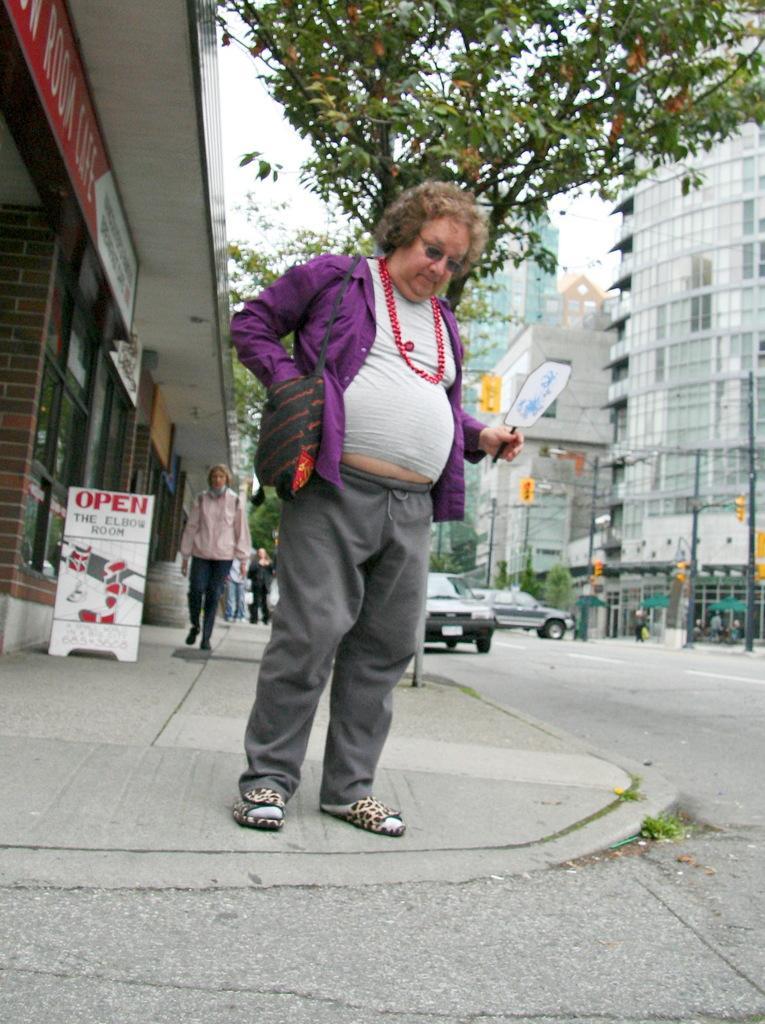Describe this image in one or two sentences. In this image we can see there are people standing on the ground and there is the other person holding an object. There are vehicles on the road and we can see the wall with windows and board with text attached to the wall. And at the right side there are buildings, trees, umbrellas, traffic lights, poles and the sky. 